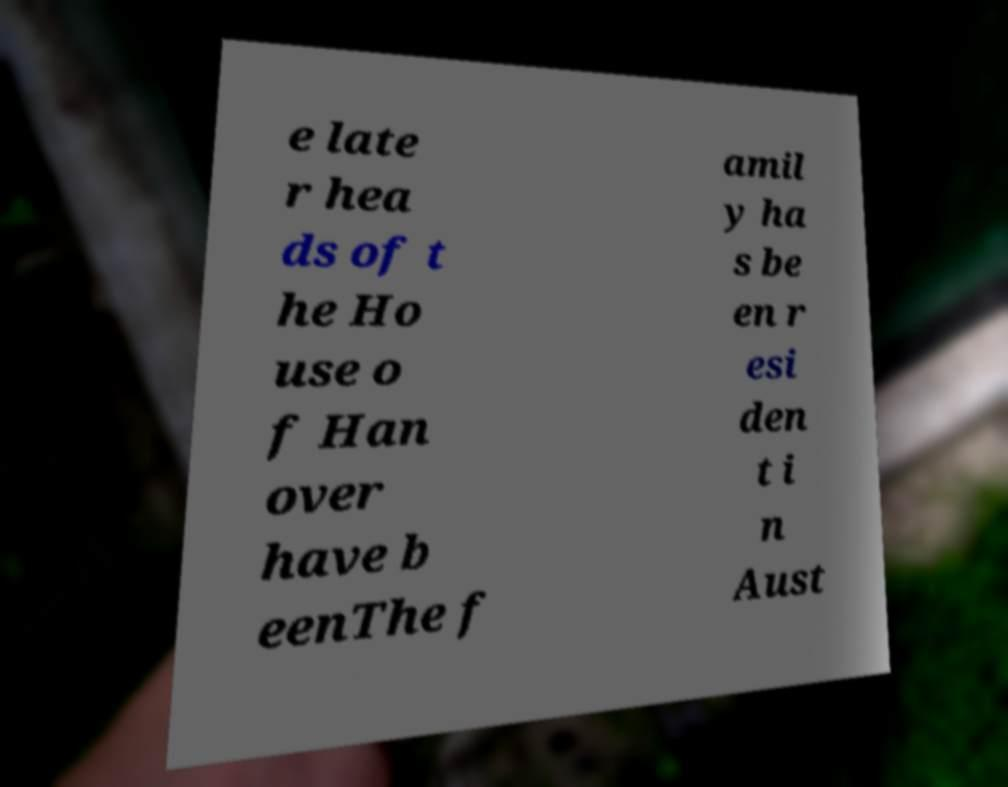Can you accurately transcribe the text from the provided image for me? e late r hea ds of t he Ho use o f Han over have b eenThe f amil y ha s be en r esi den t i n Aust 